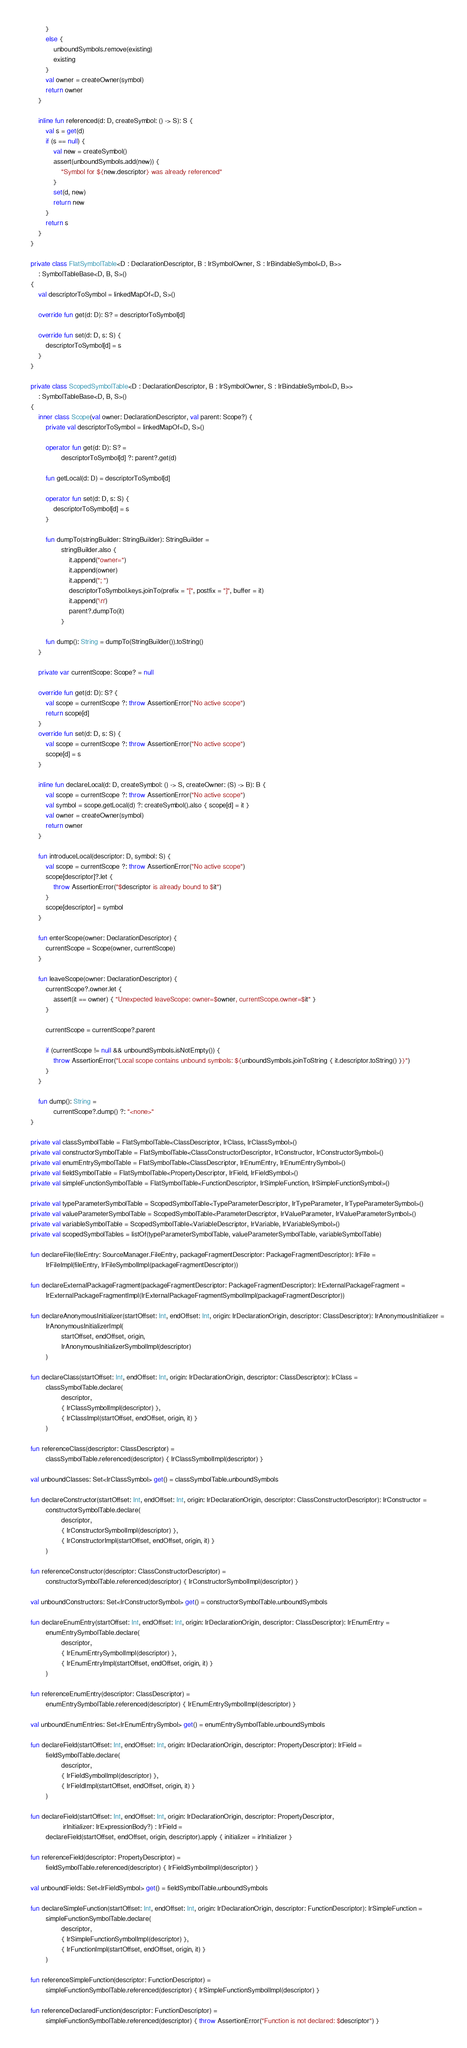<code> <loc_0><loc_0><loc_500><loc_500><_Kotlin_>            }
            else {
                unboundSymbols.remove(existing)
                existing
            }
            val owner = createOwner(symbol)
            return owner
        }

        inline fun referenced(d: D, createSymbol: () -> S): S {
            val s = get(d)
            if (s == null) {
                val new = createSymbol()
                assert(unboundSymbols.add(new)) {
                    "Symbol for ${new.descriptor} was already referenced"
                }
                set(d, new)
                return new
            }
            return s
        }
    }

    private class FlatSymbolTable<D : DeclarationDescriptor, B : IrSymbolOwner, S : IrBindableSymbol<D, B>>
        : SymbolTableBase<D, B, S>()
    {
        val descriptorToSymbol = linkedMapOf<D, S>()

        override fun get(d: D): S? = descriptorToSymbol[d]

        override fun set(d: D, s: S) {
            descriptorToSymbol[d] = s
        }
    }

    private class ScopedSymbolTable<D : DeclarationDescriptor, B : IrSymbolOwner, S : IrBindableSymbol<D, B>>
        : SymbolTableBase<D, B, S>()
    {
        inner class Scope(val owner: DeclarationDescriptor, val parent: Scope?) {
            private val descriptorToSymbol = linkedMapOf<D, S>()

            operator fun get(d: D): S? =
                    descriptorToSymbol[d] ?: parent?.get(d)

            fun getLocal(d: D) = descriptorToSymbol[d]

            operator fun set(d: D, s: S) {
                descriptorToSymbol[d] = s
            }

            fun dumpTo(stringBuilder: StringBuilder): StringBuilder =
                    stringBuilder.also {
                        it.append("owner=")
                        it.append(owner)
                        it.append("; ")
                        descriptorToSymbol.keys.joinTo(prefix = "[", postfix = "]", buffer = it)
                        it.append('\n')
                        parent?.dumpTo(it)
                    }

            fun dump(): String = dumpTo(StringBuilder()).toString()
        }

        private var currentScope: Scope? = null

        override fun get(d: D): S? {
            val scope = currentScope ?: throw AssertionError("No active scope")
            return scope[d]
        }
        override fun set(d: D, s: S) {
            val scope = currentScope ?: throw AssertionError("No active scope")
            scope[d] = s
        }

        inline fun declareLocal(d: D, createSymbol: () -> S, createOwner: (S) -> B): B {
            val scope = currentScope ?: throw AssertionError("No active scope")
            val symbol = scope.getLocal(d) ?: createSymbol().also { scope[d] = it }
            val owner = createOwner(symbol)
            return owner
        }

        fun introduceLocal(descriptor: D, symbol: S) {
            val scope = currentScope ?: throw AssertionError("No active scope")
            scope[descriptor]?.let {
                throw AssertionError("$descriptor is already bound to $it")
            }
            scope[descriptor] = symbol
        }

        fun enterScope(owner: DeclarationDescriptor) {
            currentScope = Scope(owner, currentScope)
        }

        fun leaveScope(owner: DeclarationDescriptor) {
            currentScope?.owner.let {
                assert(it == owner) { "Unexpected leaveScope: owner=$owner, currentScope.owner=$it" }
            }

            currentScope = currentScope?.parent

            if (currentScope != null && unboundSymbols.isNotEmpty()) {
                throw AssertionError("Local scope contains unbound symbols: ${unboundSymbols.joinToString { it.descriptor.toString() }}")
            }
        }

        fun dump(): String =
                currentScope?.dump() ?: "<none>"
    }

    private val classSymbolTable = FlatSymbolTable<ClassDescriptor, IrClass, IrClassSymbol>()
    private val constructorSymbolTable = FlatSymbolTable<ClassConstructorDescriptor, IrConstructor, IrConstructorSymbol>()
    private val enumEntrySymbolTable = FlatSymbolTable<ClassDescriptor, IrEnumEntry, IrEnumEntrySymbol>()
    private val fieldSymbolTable = FlatSymbolTable<PropertyDescriptor, IrField, IrFieldSymbol>()
    private val simpleFunctionSymbolTable = FlatSymbolTable<FunctionDescriptor, IrSimpleFunction, IrSimpleFunctionSymbol>()

    private val typeParameterSymbolTable = ScopedSymbolTable<TypeParameterDescriptor, IrTypeParameter, IrTypeParameterSymbol>()
    private val valueParameterSymbolTable = ScopedSymbolTable<ParameterDescriptor, IrValueParameter, IrValueParameterSymbol>()
    private val variableSymbolTable = ScopedSymbolTable<VariableDescriptor, IrVariable, IrVariableSymbol>()
    private val scopedSymbolTables = listOf(typeParameterSymbolTable, valueParameterSymbolTable, variableSymbolTable)

    fun declareFile(fileEntry: SourceManager.FileEntry, packageFragmentDescriptor: PackageFragmentDescriptor): IrFile =
            IrFileImpl(fileEntry, IrFileSymbolImpl(packageFragmentDescriptor))

    fun declareExternalPackageFragment(packageFragmentDescriptor: PackageFragmentDescriptor): IrExternalPackageFragment =
            IrExternalPackageFragmentImpl(IrExternalPackageFragmentSymbolImpl(packageFragmentDescriptor))

    fun declareAnonymousInitializer(startOffset: Int, endOffset: Int, origin: IrDeclarationOrigin, descriptor: ClassDescriptor): IrAnonymousInitializer =
            IrAnonymousInitializerImpl(
                    startOffset, endOffset, origin,
                    IrAnonymousInitializerSymbolImpl(descriptor)
            )

    fun declareClass(startOffset: Int, endOffset: Int, origin: IrDeclarationOrigin, descriptor: ClassDescriptor): IrClass =
            classSymbolTable.declare(
                    descriptor,
                    { IrClassSymbolImpl(descriptor) },
                    { IrClassImpl(startOffset, endOffset, origin, it) }
            )

    fun referenceClass(descriptor: ClassDescriptor) =
            classSymbolTable.referenced(descriptor) { IrClassSymbolImpl(descriptor) }

    val unboundClasses: Set<IrClassSymbol> get() = classSymbolTable.unboundSymbols

    fun declareConstructor(startOffset: Int, endOffset: Int, origin: IrDeclarationOrigin, descriptor: ClassConstructorDescriptor): IrConstructor =
            constructorSymbolTable.declare(
                    descriptor,
                    { IrConstructorSymbolImpl(descriptor) },
                    { IrConstructorImpl(startOffset, endOffset, origin, it) }
            )

    fun referenceConstructor(descriptor: ClassConstructorDescriptor) =
            constructorSymbolTable.referenced(descriptor) { IrConstructorSymbolImpl(descriptor) }

    val unboundConstructors: Set<IrConstructorSymbol> get() = constructorSymbolTable.unboundSymbols

    fun declareEnumEntry(startOffset: Int, endOffset: Int, origin: IrDeclarationOrigin, descriptor: ClassDescriptor): IrEnumEntry =
            enumEntrySymbolTable.declare(
                    descriptor,
                    { IrEnumEntrySymbolImpl(descriptor) },
                    { IrEnumEntryImpl(startOffset, endOffset, origin, it) }
            )

    fun referenceEnumEntry(descriptor: ClassDescriptor) =
            enumEntrySymbolTable.referenced(descriptor) { IrEnumEntrySymbolImpl(descriptor) }

    val unboundEnumEntries: Set<IrEnumEntrySymbol> get() = enumEntrySymbolTable.unboundSymbols

    fun declareField(startOffset: Int, endOffset: Int, origin: IrDeclarationOrigin, descriptor: PropertyDescriptor): IrField =
            fieldSymbolTable.declare(
                    descriptor,
                    { IrFieldSymbolImpl(descriptor) },
                    { IrFieldImpl(startOffset, endOffset, origin, it) }
            )

    fun declareField(startOffset: Int, endOffset: Int, origin: IrDeclarationOrigin, descriptor: PropertyDescriptor,
                     irInitializer: IrExpressionBody?) : IrField =
            declareField(startOffset, endOffset, origin, descriptor).apply { initializer = irInitializer }

    fun referenceField(descriptor: PropertyDescriptor) =
            fieldSymbolTable.referenced(descriptor) { IrFieldSymbolImpl(descriptor) }

    val unboundFields: Set<IrFieldSymbol> get() = fieldSymbolTable.unboundSymbols

    fun declareSimpleFunction(startOffset: Int, endOffset: Int, origin: IrDeclarationOrigin, descriptor: FunctionDescriptor): IrSimpleFunction =
            simpleFunctionSymbolTable.declare(
                    descriptor,
                    { IrSimpleFunctionSymbolImpl(descriptor) },
                    { IrFunctionImpl(startOffset, endOffset, origin, it) }
            )

    fun referenceSimpleFunction(descriptor: FunctionDescriptor) =
            simpleFunctionSymbolTable.referenced(descriptor) { IrSimpleFunctionSymbolImpl(descriptor) }

    fun referenceDeclaredFunction(descriptor: FunctionDescriptor) =
            simpleFunctionSymbolTable.referenced(descriptor) { throw AssertionError("Function is not declared: $descriptor") }
</code> 